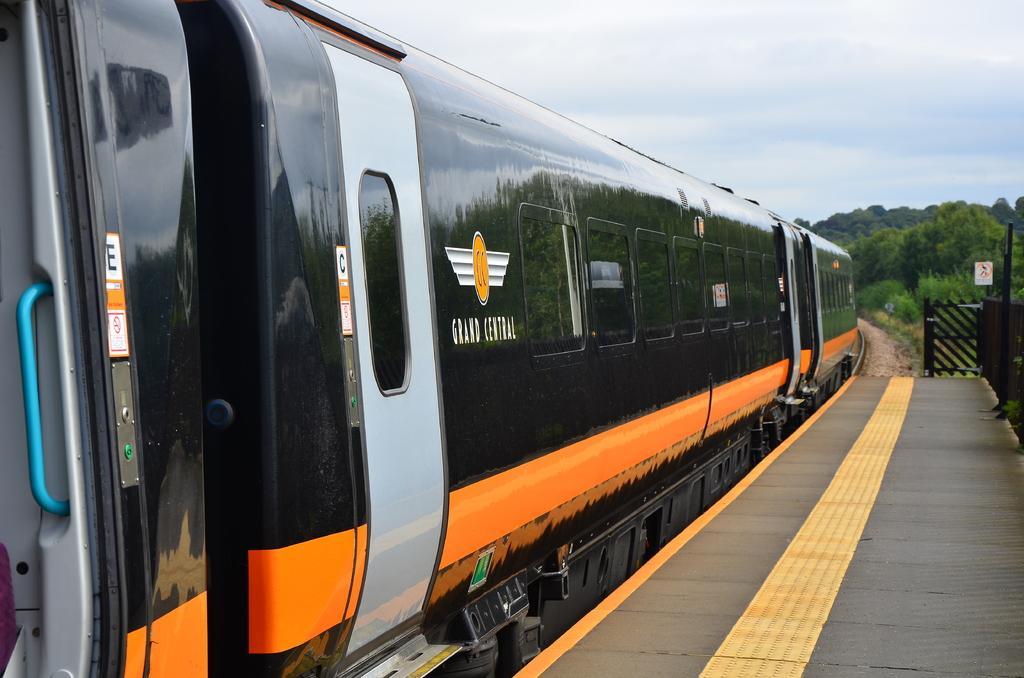Describe this image in one or two sentences. In this image I can see a train on railway track. Here I can see a railway platform, fence and trees. In the background I can see the sky. 